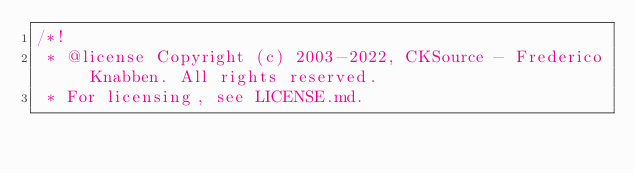<code> <loc_0><loc_0><loc_500><loc_500><_JavaScript_>/*!
 * @license Copyright (c) 2003-2022, CKSource - Frederico Knabben. All rights reserved.
 * For licensing, see LICENSE.md.</code> 